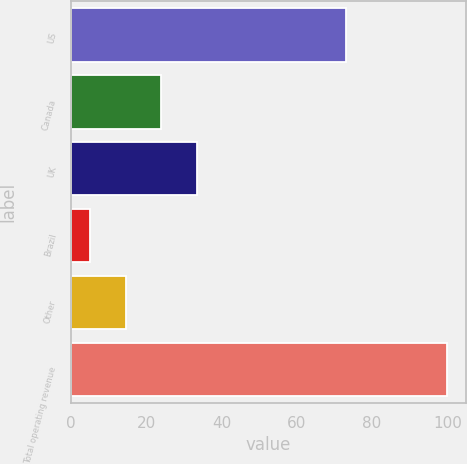Convert chart. <chart><loc_0><loc_0><loc_500><loc_500><bar_chart><fcel>US<fcel>Canada<fcel>UK<fcel>Brazil<fcel>Other<fcel>Total operating revenue<nl><fcel>73<fcel>24<fcel>33.5<fcel>5<fcel>14.5<fcel>100<nl></chart> 